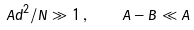<formula> <loc_0><loc_0><loc_500><loc_500>A d ^ { 2 } / N \gg 1 \, , \quad A - B \ll A</formula> 